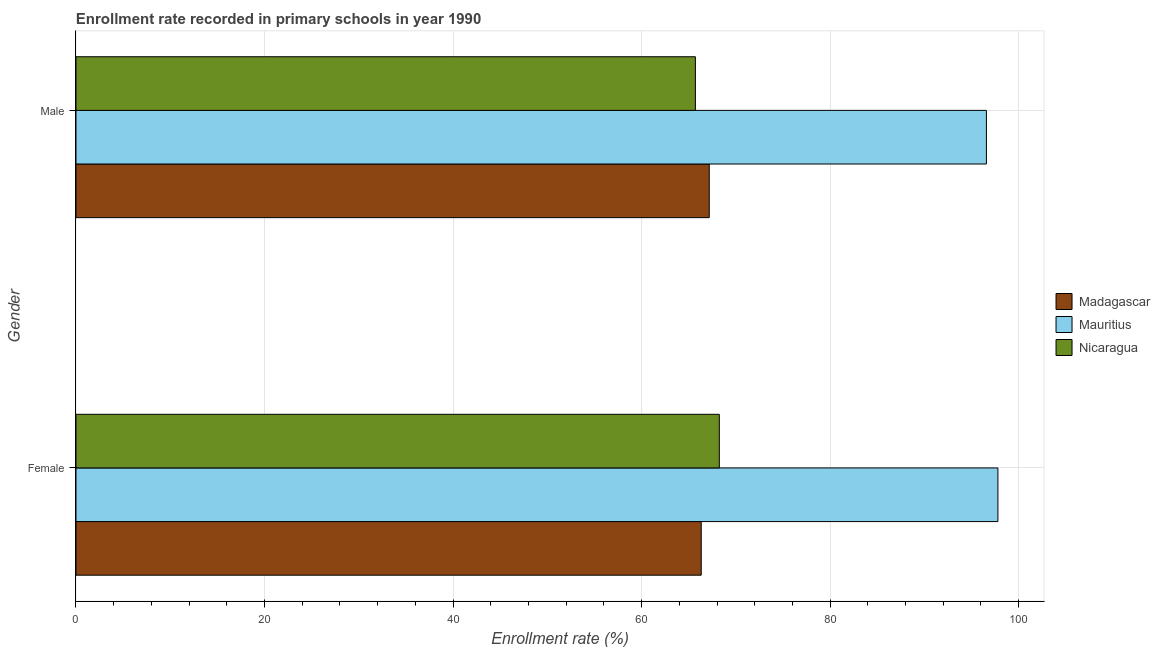How many groups of bars are there?
Keep it short and to the point. 2. How many bars are there on the 2nd tick from the top?
Provide a short and direct response. 3. How many bars are there on the 1st tick from the bottom?
Your answer should be compact. 3. What is the enrollment rate of female students in Nicaragua?
Provide a short and direct response. 68.24. Across all countries, what is the maximum enrollment rate of female students?
Make the answer very short. 97.8. Across all countries, what is the minimum enrollment rate of male students?
Provide a succinct answer. 65.71. In which country was the enrollment rate of male students maximum?
Ensure brevity in your answer.  Mauritius. In which country was the enrollment rate of female students minimum?
Ensure brevity in your answer.  Madagascar. What is the total enrollment rate of female students in the graph?
Make the answer very short. 232.37. What is the difference between the enrollment rate of female students in Mauritius and that in Nicaragua?
Provide a succinct answer. 29.55. What is the difference between the enrollment rate of female students in Madagascar and the enrollment rate of male students in Mauritius?
Ensure brevity in your answer.  -30.26. What is the average enrollment rate of female students per country?
Your answer should be compact. 77.46. What is the difference between the enrollment rate of female students and enrollment rate of male students in Madagascar?
Provide a succinct answer. -0.85. In how many countries, is the enrollment rate of female students greater than 8 %?
Your answer should be compact. 3. What is the ratio of the enrollment rate of male students in Mauritius to that in Nicaragua?
Keep it short and to the point. 1.47. What does the 2nd bar from the top in Male represents?
Your answer should be very brief. Mauritius. What does the 3rd bar from the bottom in Female represents?
Your response must be concise. Nicaragua. Are all the bars in the graph horizontal?
Offer a very short reply. Yes. How many countries are there in the graph?
Give a very brief answer. 3. Are the values on the major ticks of X-axis written in scientific E-notation?
Your answer should be compact. No. Does the graph contain grids?
Provide a succinct answer. Yes. Where does the legend appear in the graph?
Your response must be concise. Center right. What is the title of the graph?
Provide a succinct answer. Enrollment rate recorded in primary schools in year 1990. What is the label or title of the X-axis?
Keep it short and to the point. Enrollment rate (%). What is the label or title of the Y-axis?
Ensure brevity in your answer.  Gender. What is the Enrollment rate (%) of Madagascar in Female?
Make the answer very short. 66.32. What is the Enrollment rate (%) of Mauritius in Female?
Provide a short and direct response. 97.8. What is the Enrollment rate (%) in Nicaragua in Female?
Your answer should be very brief. 68.24. What is the Enrollment rate (%) in Madagascar in Male?
Provide a succinct answer. 67.18. What is the Enrollment rate (%) of Mauritius in Male?
Make the answer very short. 96.58. What is the Enrollment rate (%) in Nicaragua in Male?
Ensure brevity in your answer.  65.71. Across all Gender, what is the maximum Enrollment rate (%) of Madagascar?
Provide a short and direct response. 67.18. Across all Gender, what is the maximum Enrollment rate (%) of Mauritius?
Offer a very short reply. 97.8. Across all Gender, what is the maximum Enrollment rate (%) in Nicaragua?
Keep it short and to the point. 68.24. Across all Gender, what is the minimum Enrollment rate (%) of Madagascar?
Your answer should be very brief. 66.32. Across all Gender, what is the minimum Enrollment rate (%) in Mauritius?
Make the answer very short. 96.58. Across all Gender, what is the minimum Enrollment rate (%) in Nicaragua?
Provide a short and direct response. 65.71. What is the total Enrollment rate (%) in Madagascar in the graph?
Ensure brevity in your answer.  133.5. What is the total Enrollment rate (%) of Mauritius in the graph?
Give a very brief answer. 194.38. What is the total Enrollment rate (%) of Nicaragua in the graph?
Offer a terse response. 133.95. What is the difference between the Enrollment rate (%) of Madagascar in Female and that in Male?
Provide a short and direct response. -0.85. What is the difference between the Enrollment rate (%) of Mauritius in Female and that in Male?
Make the answer very short. 1.22. What is the difference between the Enrollment rate (%) of Nicaragua in Female and that in Male?
Your answer should be very brief. 2.54. What is the difference between the Enrollment rate (%) of Madagascar in Female and the Enrollment rate (%) of Mauritius in Male?
Offer a terse response. -30.26. What is the difference between the Enrollment rate (%) of Madagascar in Female and the Enrollment rate (%) of Nicaragua in Male?
Give a very brief answer. 0.62. What is the difference between the Enrollment rate (%) of Mauritius in Female and the Enrollment rate (%) of Nicaragua in Male?
Give a very brief answer. 32.09. What is the average Enrollment rate (%) in Madagascar per Gender?
Keep it short and to the point. 66.75. What is the average Enrollment rate (%) in Mauritius per Gender?
Keep it short and to the point. 97.19. What is the average Enrollment rate (%) of Nicaragua per Gender?
Your response must be concise. 66.97. What is the difference between the Enrollment rate (%) of Madagascar and Enrollment rate (%) of Mauritius in Female?
Ensure brevity in your answer.  -31.48. What is the difference between the Enrollment rate (%) in Madagascar and Enrollment rate (%) in Nicaragua in Female?
Your answer should be compact. -1.92. What is the difference between the Enrollment rate (%) of Mauritius and Enrollment rate (%) of Nicaragua in Female?
Give a very brief answer. 29.55. What is the difference between the Enrollment rate (%) in Madagascar and Enrollment rate (%) in Mauritius in Male?
Keep it short and to the point. -29.4. What is the difference between the Enrollment rate (%) in Madagascar and Enrollment rate (%) in Nicaragua in Male?
Give a very brief answer. 1.47. What is the difference between the Enrollment rate (%) of Mauritius and Enrollment rate (%) of Nicaragua in Male?
Your response must be concise. 30.87. What is the ratio of the Enrollment rate (%) in Madagascar in Female to that in Male?
Ensure brevity in your answer.  0.99. What is the ratio of the Enrollment rate (%) of Mauritius in Female to that in Male?
Ensure brevity in your answer.  1.01. What is the ratio of the Enrollment rate (%) in Nicaragua in Female to that in Male?
Keep it short and to the point. 1.04. What is the difference between the highest and the second highest Enrollment rate (%) of Madagascar?
Provide a short and direct response. 0.85. What is the difference between the highest and the second highest Enrollment rate (%) in Mauritius?
Make the answer very short. 1.22. What is the difference between the highest and the second highest Enrollment rate (%) of Nicaragua?
Your answer should be compact. 2.54. What is the difference between the highest and the lowest Enrollment rate (%) in Madagascar?
Your response must be concise. 0.85. What is the difference between the highest and the lowest Enrollment rate (%) of Mauritius?
Provide a short and direct response. 1.22. What is the difference between the highest and the lowest Enrollment rate (%) in Nicaragua?
Keep it short and to the point. 2.54. 